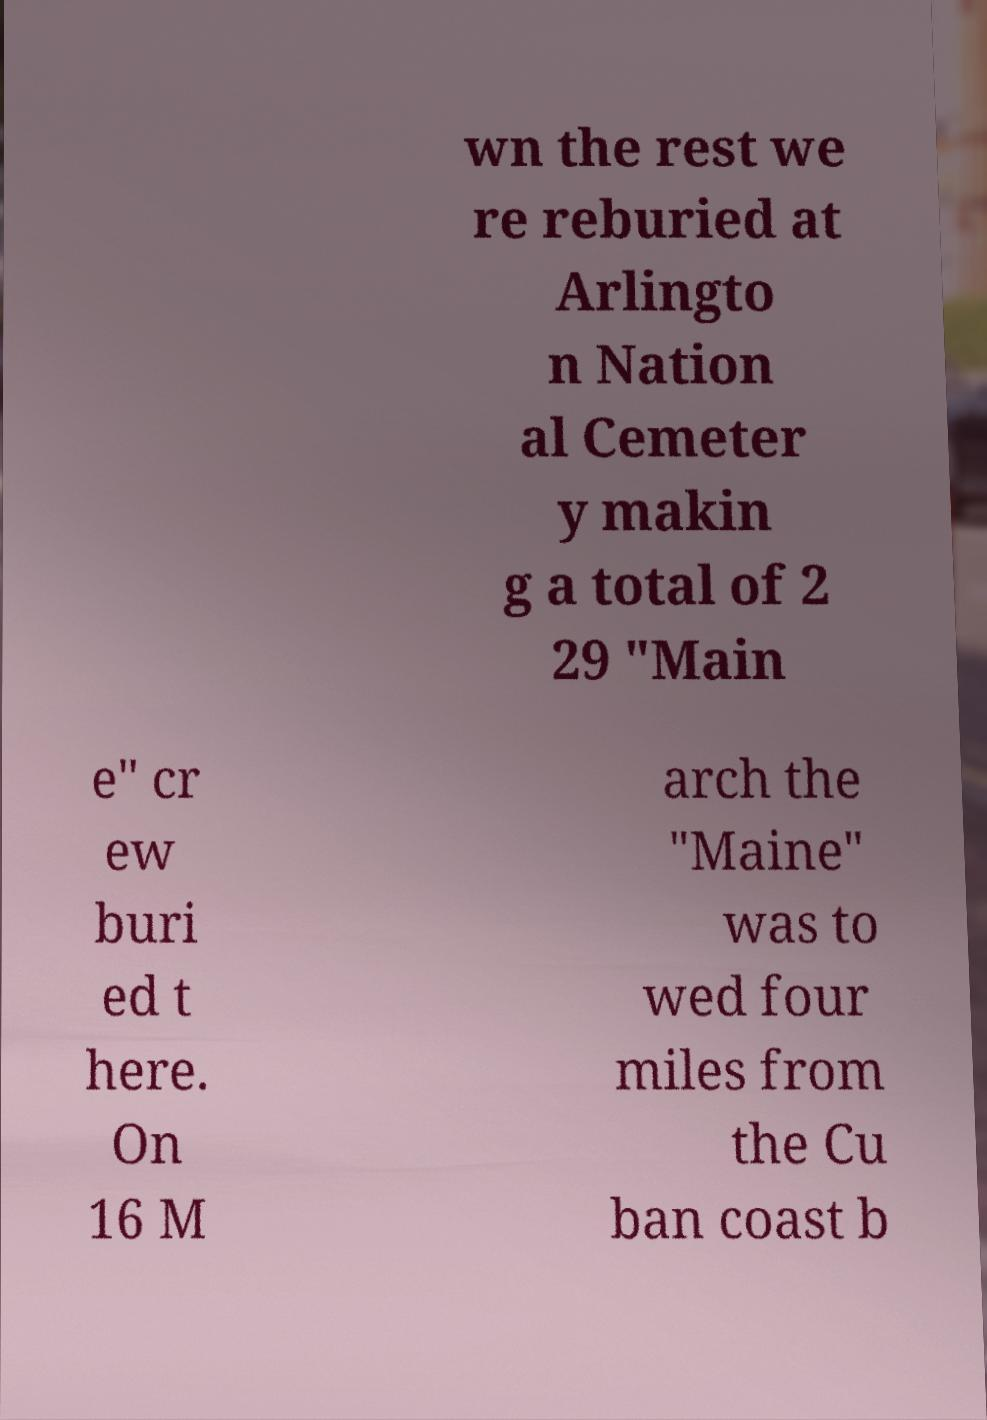Could you assist in decoding the text presented in this image and type it out clearly? wn the rest we re reburied at Arlingto n Nation al Cemeter y makin g a total of 2 29 "Main e" cr ew buri ed t here. On 16 M arch the "Maine" was to wed four miles from the Cu ban coast b 